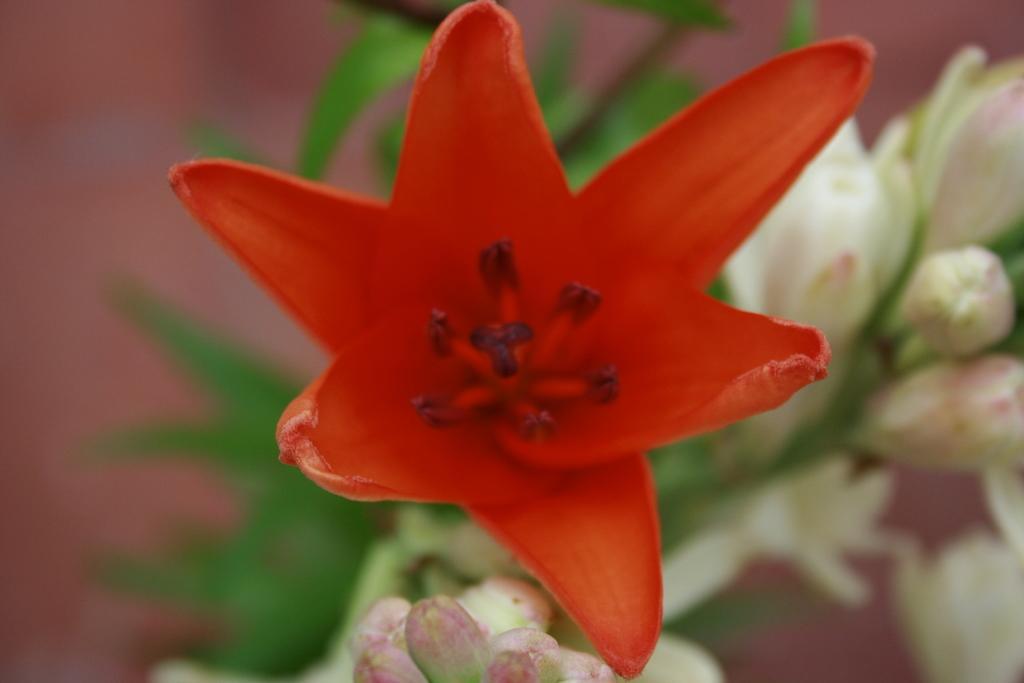Please provide a concise description of this image. In this image, we can see a plant and some flowers. We can also see the blurred background. 